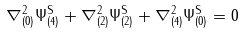Convert formula to latex. <formula><loc_0><loc_0><loc_500><loc_500>\nabla _ { ( 0 ) } ^ { 2 } \Psi _ { ( 4 ) } ^ { \text {S} } + \nabla _ { ( 2 ) } ^ { 2 } \Psi _ { ( 2 ) } ^ { \text {S} } + \nabla _ { ( 4 ) } ^ { 2 } \Psi _ { ( 0 ) } ^ { \text {S} } = 0</formula> 